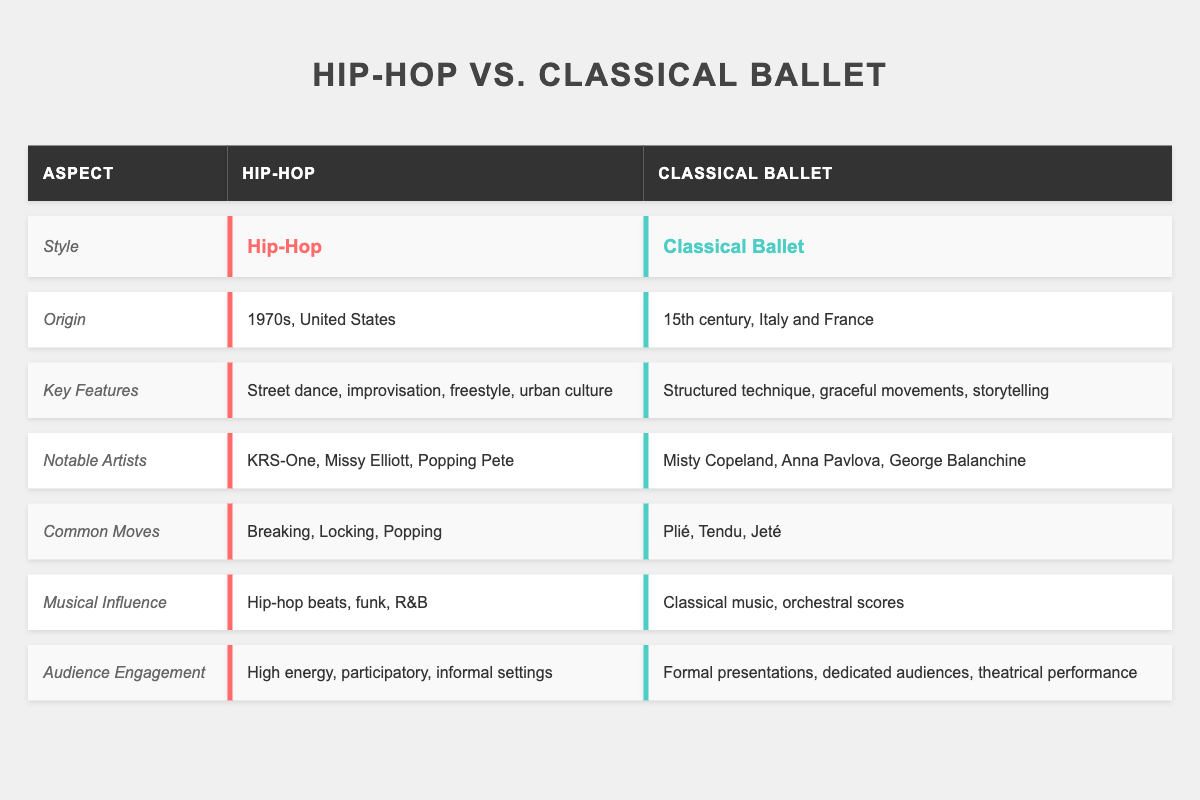What is the origin of Hip-Hop? The table indicates that Hip-Hop originated in the 1970s in the United States.
Answer: 1970s, United States Who are two notable artists in Classical Ballet? The table lists Misty Copeland and Anna Pavlova as notable artists in Classical Ballet.
Answer: Misty Copeland, Anna Pavlova Which dance style emphasizes improvisation? Hip-Hop is highlighted in the table as having improvisation as a key feature.
Answer: Hip-Hop What are the common moves associated with Classical Ballet? The table specifies that common moves in Classical Ballet include Plié, Tendu, and Jeté.
Answer: Plié, Tendu, Jeté Does Hip-Hop have formal audience presentations? According to the table, Hip-Hop is characterized by high energy and participatory engagement, which means it does not feature formal presentations.
Answer: No Which dance style has a stronger focus on storytelling? The table states that Classical Ballet emphasizes storytelling, while Hip-Hop is rooted in urban culture.
Answer: Classical Ballet What is the musical influence of Hip-Hop? The table reveals that Hip-Hop is influenced by hip-hop beats, funk, and R&B music.
Answer: Hip-hop beats, funk, R&B How would you compare the audience engagement between Hip-Hop and Classical Ballet? The table shows that Hip-Hop has high energy and informal settings for audience engagement, whereas Classical Ballet features formal presentations for dedicated audiences.
Answer: Hip-Hop - high energy; Classical Ballet - formal What are the key features of Classical Ballet, and how do they differ from Hip-Hop? The table describes Classical Ballet's features as structured technique, graceful movements, and storytelling, while Hip-Hop is characterized by street dance, improvisation, freestyle, and urban culture, showcasing significant differences.
Answer: Structured technique, graceful movements, storytelling vs. street dance, improvisation, freestyle, urban culture Which dance style includes breaking, locking, and popping in its common moves? The table identifies these moves as associated specifically with Hip-Hop.
Answer: Hip-Hop Are any of the notable artists for Hip-Hop listed also known for Classical Ballet? The table clearly separates the notable artists for each style, showing no overlap between Hip-Hop and Classical Ballet artists.
Answer: No 